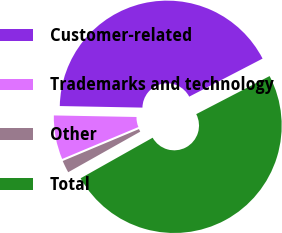Convert chart. <chart><loc_0><loc_0><loc_500><loc_500><pie_chart><fcel>Customer-related<fcel>Trademarks and technology<fcel>Other<fcel>Total<nl><fcel>42.08%<fcel>6.61%<fcel>1.85%<fcel>49.45%<nl></chart> 